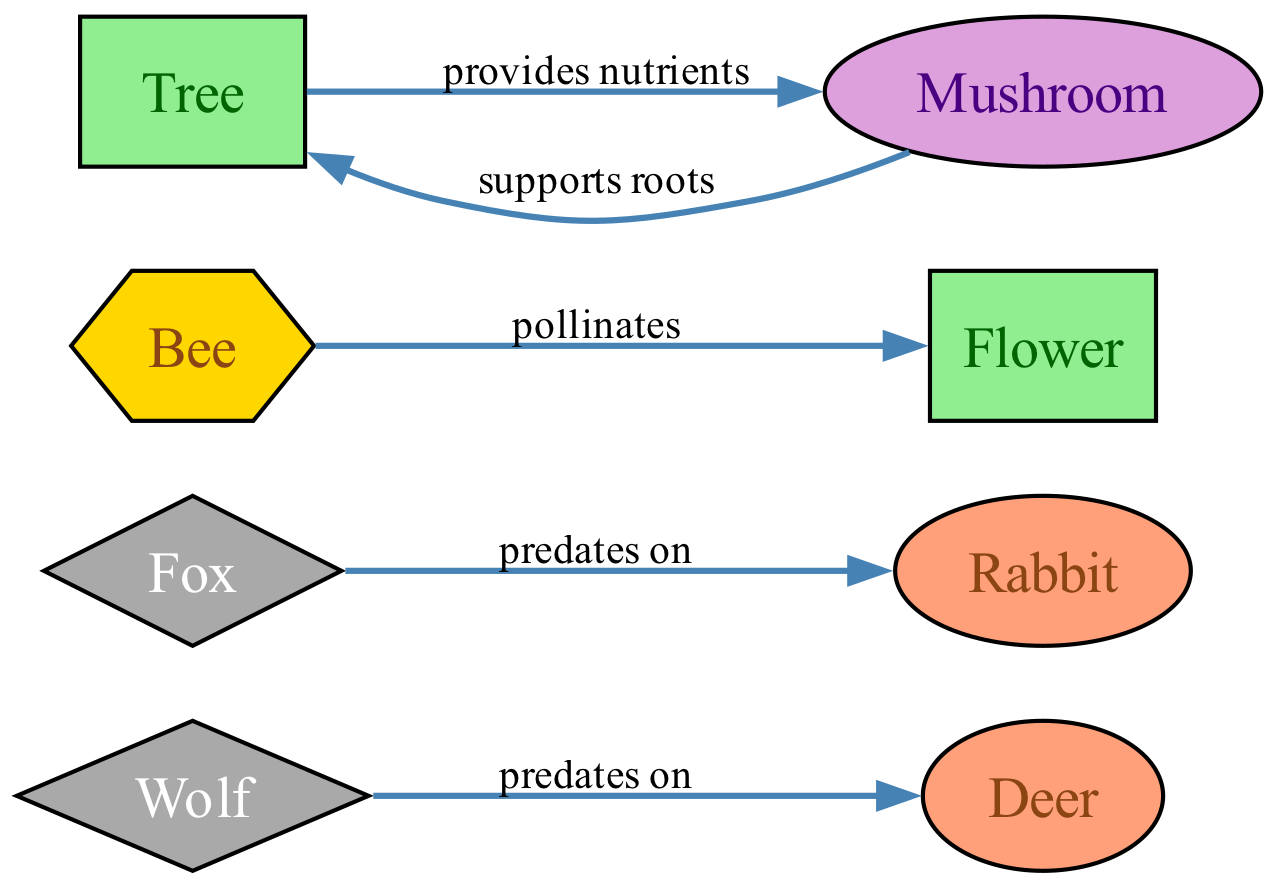What is the total number of nodes in the diagram? The diagram contains 8 nodes, which are Deer, Wolf, Rabbit, Fox, Flower, Bee, Tree, and Mushroom. Counting each of these gives a total of 8 nodes.
Answer: 8 How many predator nodes are represented in the diagram? The diagram includes two predator nodes: Wolf and Fox. By counting them, we find there are 2 predator nodes.
Answer: 2 Which organism pollinates the flower? The diagram shows that the Bee is the entity that pollinates the Flower, as indicated by the edge labeled "pollinates" pointing from Bee to Flower.
Answer: Bee What supports the roots of the tree? According to the diagram, the Mushroom supports the roots of the Tree, as indicated by the edge labeled "supports roots" pointing from Mushroom to Tree.
Answer: Mushroom How many edges are present in the diagram? There are 5 edges present, connecting various nodes based on the relationships defined in the diagram. The edges are Wolf→Deer, Fox→Rabbit, Bee→Flower, Mushroom→Tree, and Tree→Mushroom.
Answer: 5 Which two nodes have a mutualistic relationship? The relationship between Tree and Mushroom is mutualistic, characterized by Tree providing nutrients to Mushroom and Mushroom supporting roots, suggesting a mutual benefit.
Answer: Tree and Mushroom Which prey is associated with the wolf? The edge connecting the Wolf to the Deer indicates that the Wolf preys on the Deer, giving the specific prey associated with this predator.
Answer: Deer What type of relationship does the fox have with the rabbit? The relationship is a predatory one, as indicated by the edge labeled "predates on" from Fox to Rabbit. This clearly shows the type of interaction between these two nodes.
Answer: predatory 